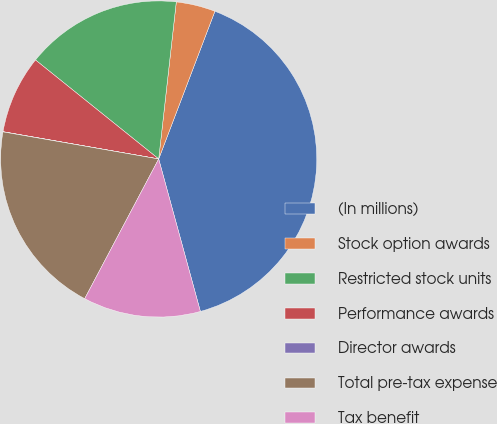<chart> <loc_0><loc_0><loc_500><loc_500><pie_chart><fcel>(In millions)<fcel>Stock option awards<fcel>Restricted stock units<fcel>Performance awards<fcel>Director awards<fcel>Total pre-tax expense<fcel>Tax benefit<nl><fcel>39.96%<fcel>4.01%<fcel>16.0%<fcel>8.01%<fcel>0.02%<fcel>19.99%<fcel>12.0%<nl></chart> 